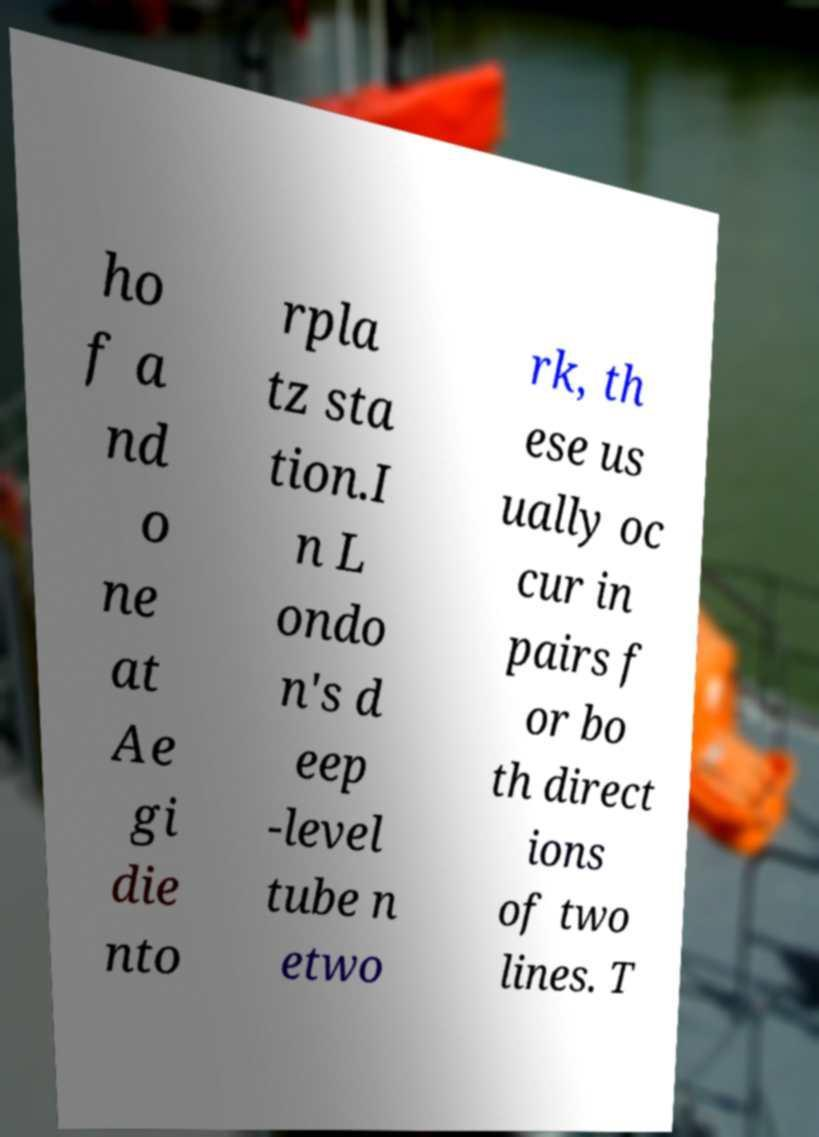For documentation purposes, I need the text within this image transcribed. Could you provide that? ho f a nd o ne at Ae gi die nto rpla tz sta tion.I n L ondo n's d eep -level tube n etwo rk, th ese us ually oc cur in pairs f or bo th direct ions of two lines. T 